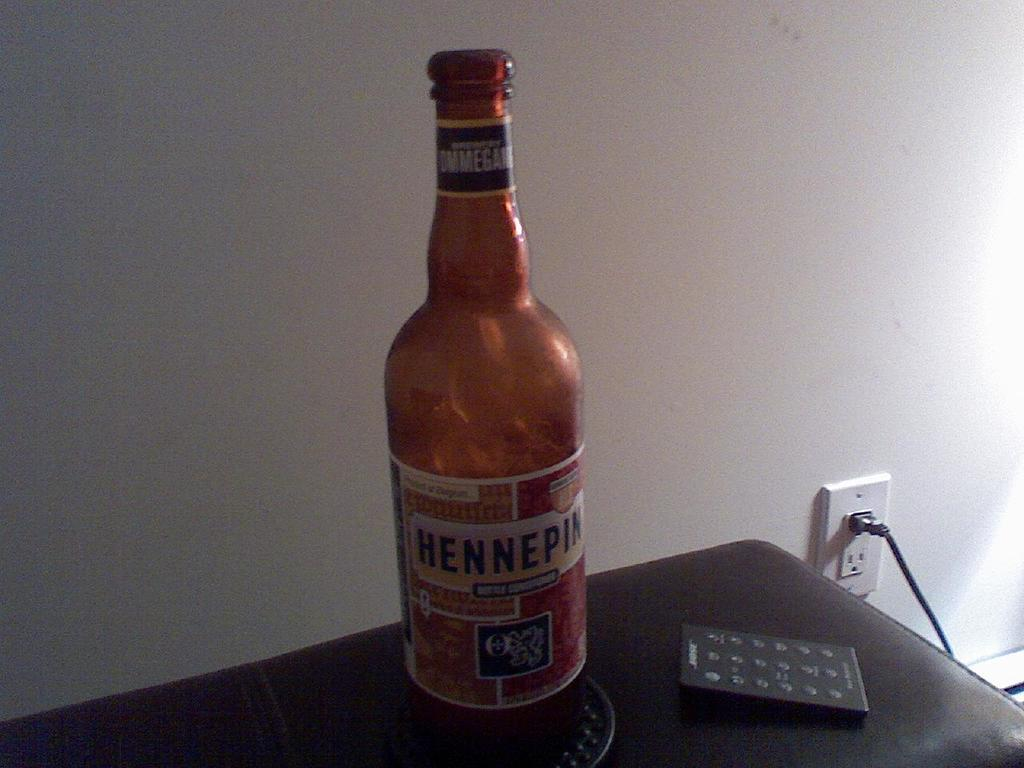<image>
Offer a succinct explanation of the picture presented. A bottle of Hennepin  next to a remote control 